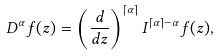<formula> <loc_0><loc_0><loc_500><loc_500>D ^ { \alpha } f ( z ) = \left ( \frac { d } { d z } \right ) ^ { \lceil \alpha \rceil } I ^ { \lceil \alpha \rceil - \alpha } f ( z ) ,</formula> 